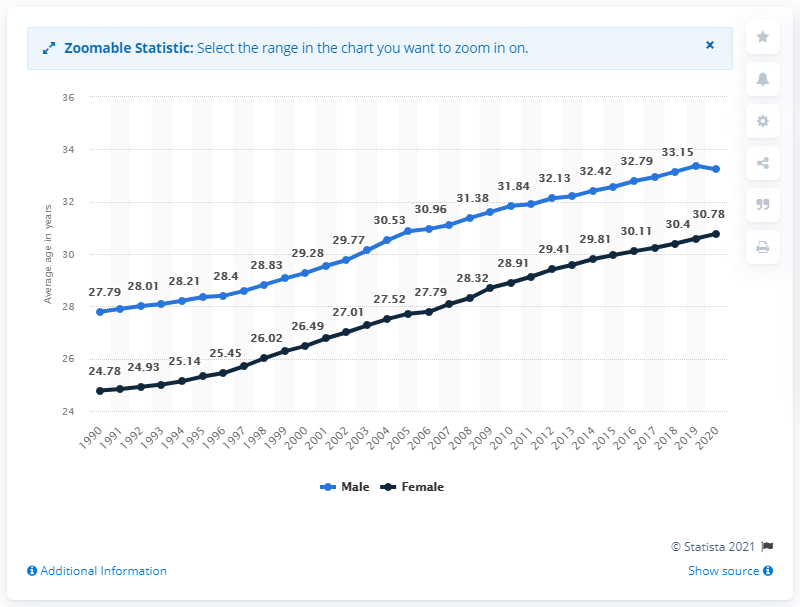Point out several critical features in this image. In 2020, the average age at which women in South Korea first married reached an all-time high. 